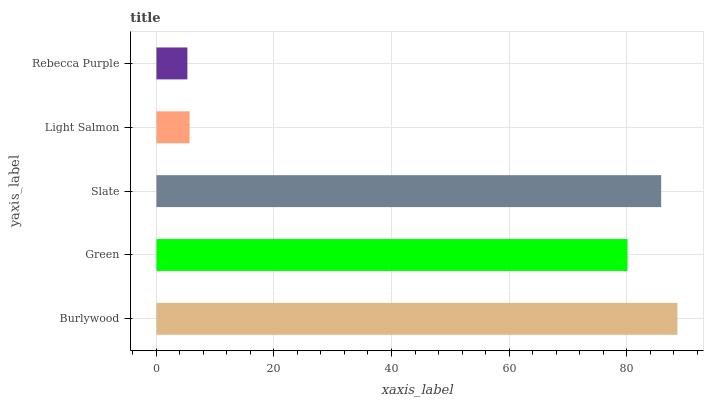Is Rebecca Purple the minimum?
Answer yes or no. Yes. Is Burlywood the maximum?
Answer yes or no. Yes. Is Green the minimum?
Answer yes or no. No. Is Green the maximum?
Answer yes or no. No. Is Burlywood greater than Green?
Answer yes or no. Yes. Is Green less than Burlywood?
Answer yes or no. Yes. Is Green greater than Burlywood?
Answer yes or no. No. Is Burlywood less than Green?
Answer yes or no. No. Is Green the high median?
Answer yes or no. Yes. Is Green the low median?
Answer yes or no. Yes. Is Rebecca Purple the high median?
Answer yes or no. No. Is Slate the low median?
Answer yes or no. No. 